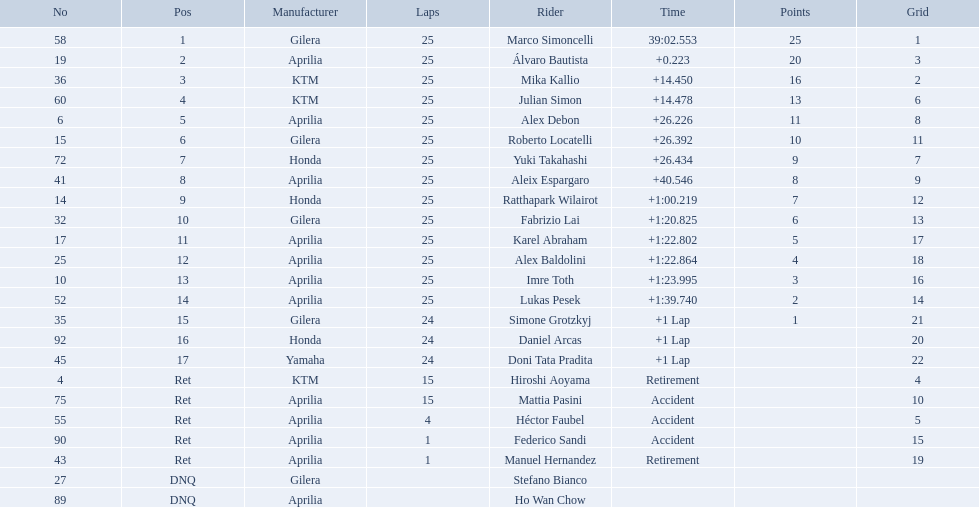What was the fastest overall time? 39:02.553. Who does this time belong to? Marco Simoncelli. Who were all of the riders? Marco Simoncelli, Álvaro Bautista, Mika Kallio, Julian Simon, Alex Debon, Roberto Locatelli, Yuki Takahashi, Aleix Espargaro, Ratthapark Wilairot, Fabrizio Lai, Karel Abraham, Alex Baldolini, Imre Toth, Lukas Pesek, Simone Grotzkyj, Daniel Arcas, Doni Tata Pradita, Hiroshi Aoyama, Mattia Pasini, Héctor Faubel, Federico Sandi, Manuel Hernandez, Stefano Bianco, Ho Wan Chow. How many laps did they complete? 25, 25, 25, 25, 25, 25, 25, 25, 25, 25, 25, 25, 25, 25, 24, 24, 24, 15, 15, 4, 1, 1, , . Between marco simoncelli and hiroshi aoyama, who had more laps? Marco Simoncelli. How many laps did marco perform? 25. How many laps did hiroshi perform? 15. Which of these numbers are higher? 25. Who swam this number of laps? Marco Simoncelli. How many laps did hiroshi aoyama perform? 15. How many laps did marco simoncelli perform? 25. Who performed more laps out of hiroshi aoyama and marco 
simoncelli? Marco Simoncelli. Who are all the riders? Marco Simoncelli, Álvaro Bautista, Mika Kallio, Julian Simon, Alex Debon, Roberto Locatelli, Yuki Takahashi, Aleix Espargaro, Ratthapark Wilairot, Fabrizio Lai, Karel Abraham, Alex Baldolini, Imre Toth, Lukas Pesek, Simone Grotzkyj, Daniel Arcas, Doni Tata Pradita, Hiroshi Aoyama, Mattia Pasini, Héctor Faubel, Federico Sandi, Manuel Hernandez, Stefano Bianco, Ho Wan Chow. Which held rank 1? Marco Simoncelli. 